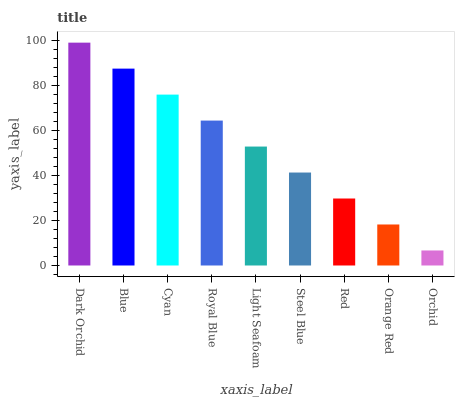Is Orchid the minimum?
Answer yes or no. Yes. Is Dark Orchid the maximum?
Answer yes or no. Yes. Is Blue the minimum?
Answer yes or no. No. Is Blue the maximum?
Answer yes or no. No. Is Dark Orchid greater than Blue?
Answer yes or no. Yes. Is Blue less than Dark Orchid?
Answer yes or no. Yes. Is Blue greater than Dark Orchid?
Answer yes or no. No. Is Dark Orchid less than Blue?
Answer yes or no. No. Is Light Seafoam the high median?
Answer yes or no. Yes. Is Light Seafoam the low median?
Answer yes or no. Yes. Is Red the high median?
Answer yes or no. No. Is Steel Blue the low median?
Answer yes or no. No. 